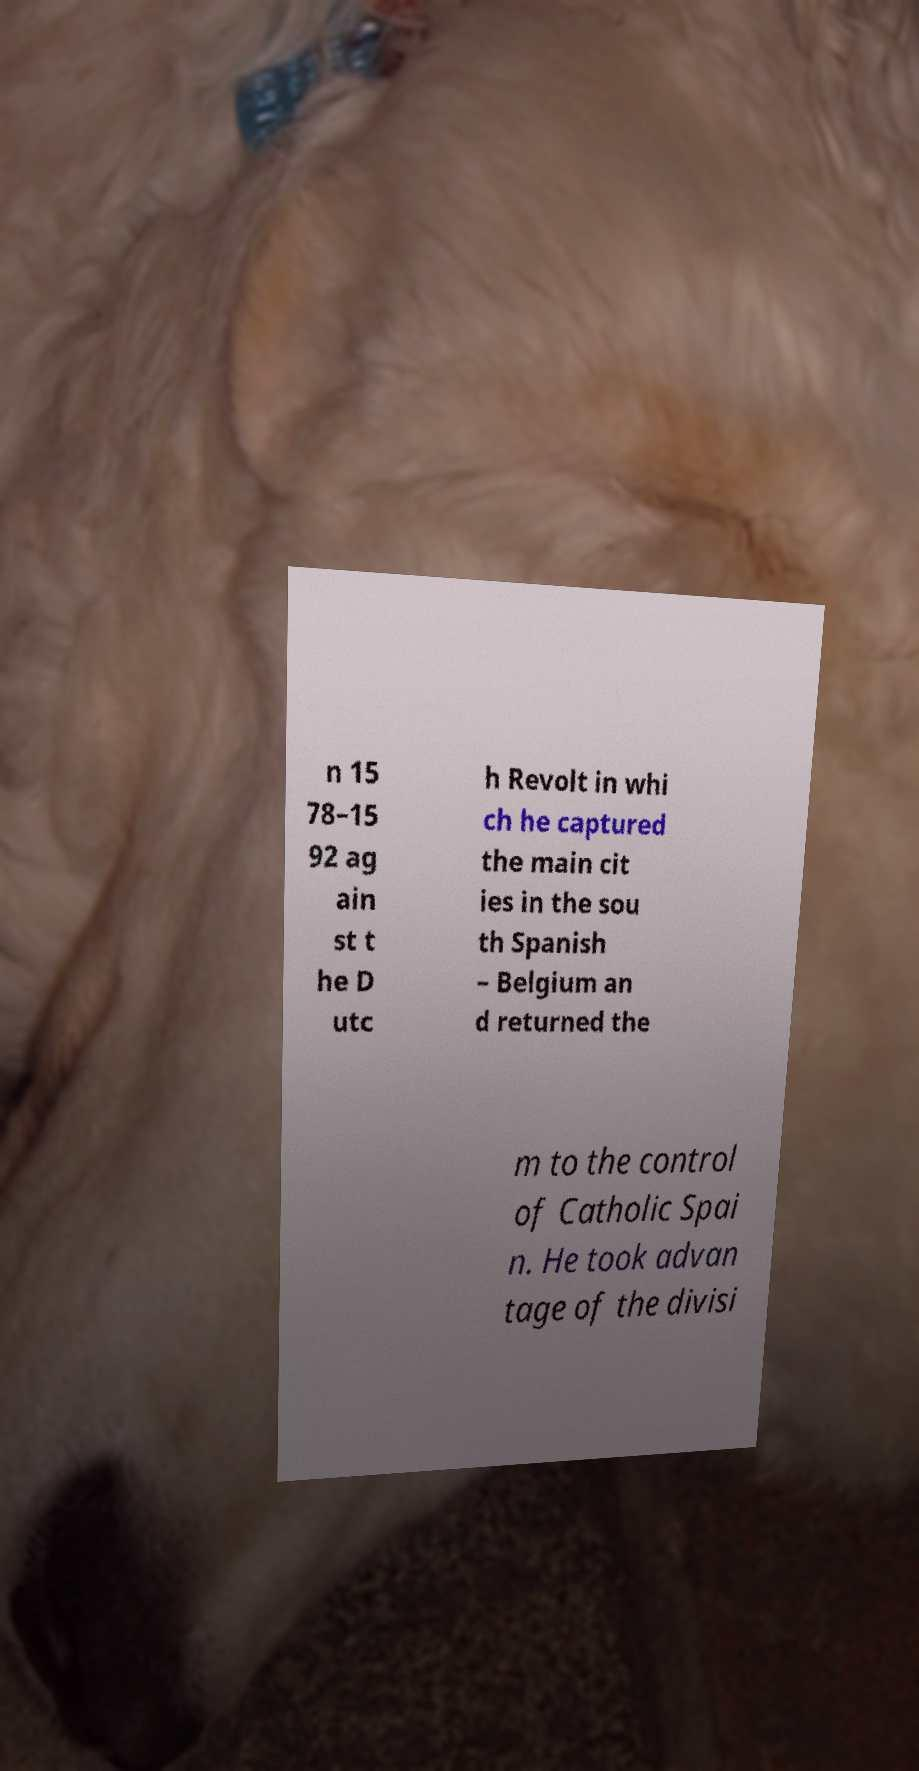There's text embedded in this image that I need extracted. Can you transcribe it verbatim? n 15 78–15 92 ag ain st t he D utc h Revolt in whi ch he captured the main cit ies in the sou th Spanish – Belgium an d returned the m to the control of Catholic Spai n. He took advan tage of the divisi 